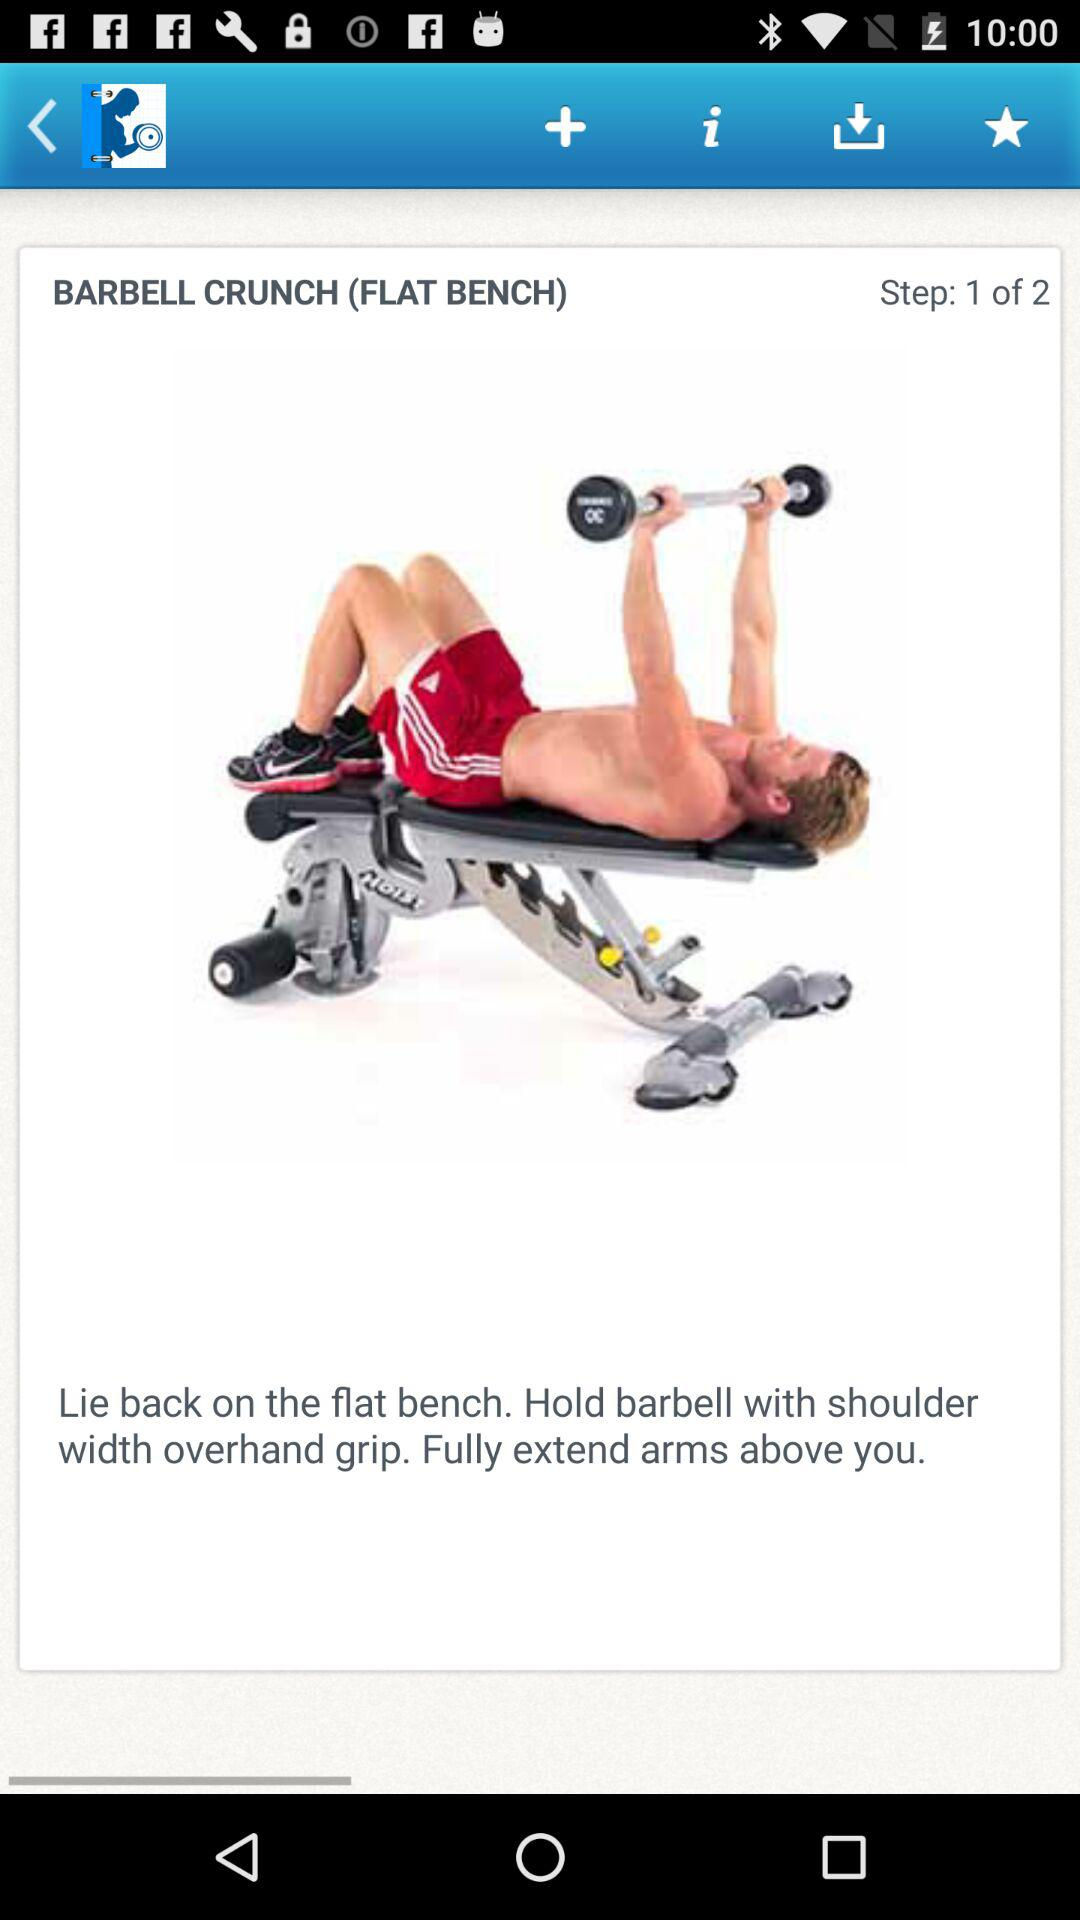How many steps in total are there? The total number of steps is 2. 